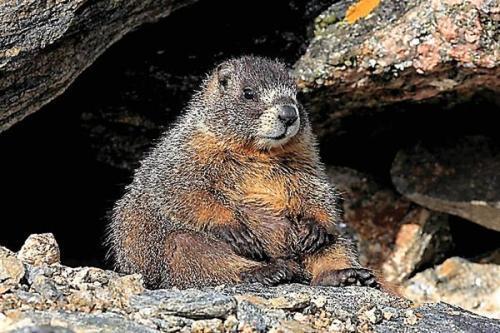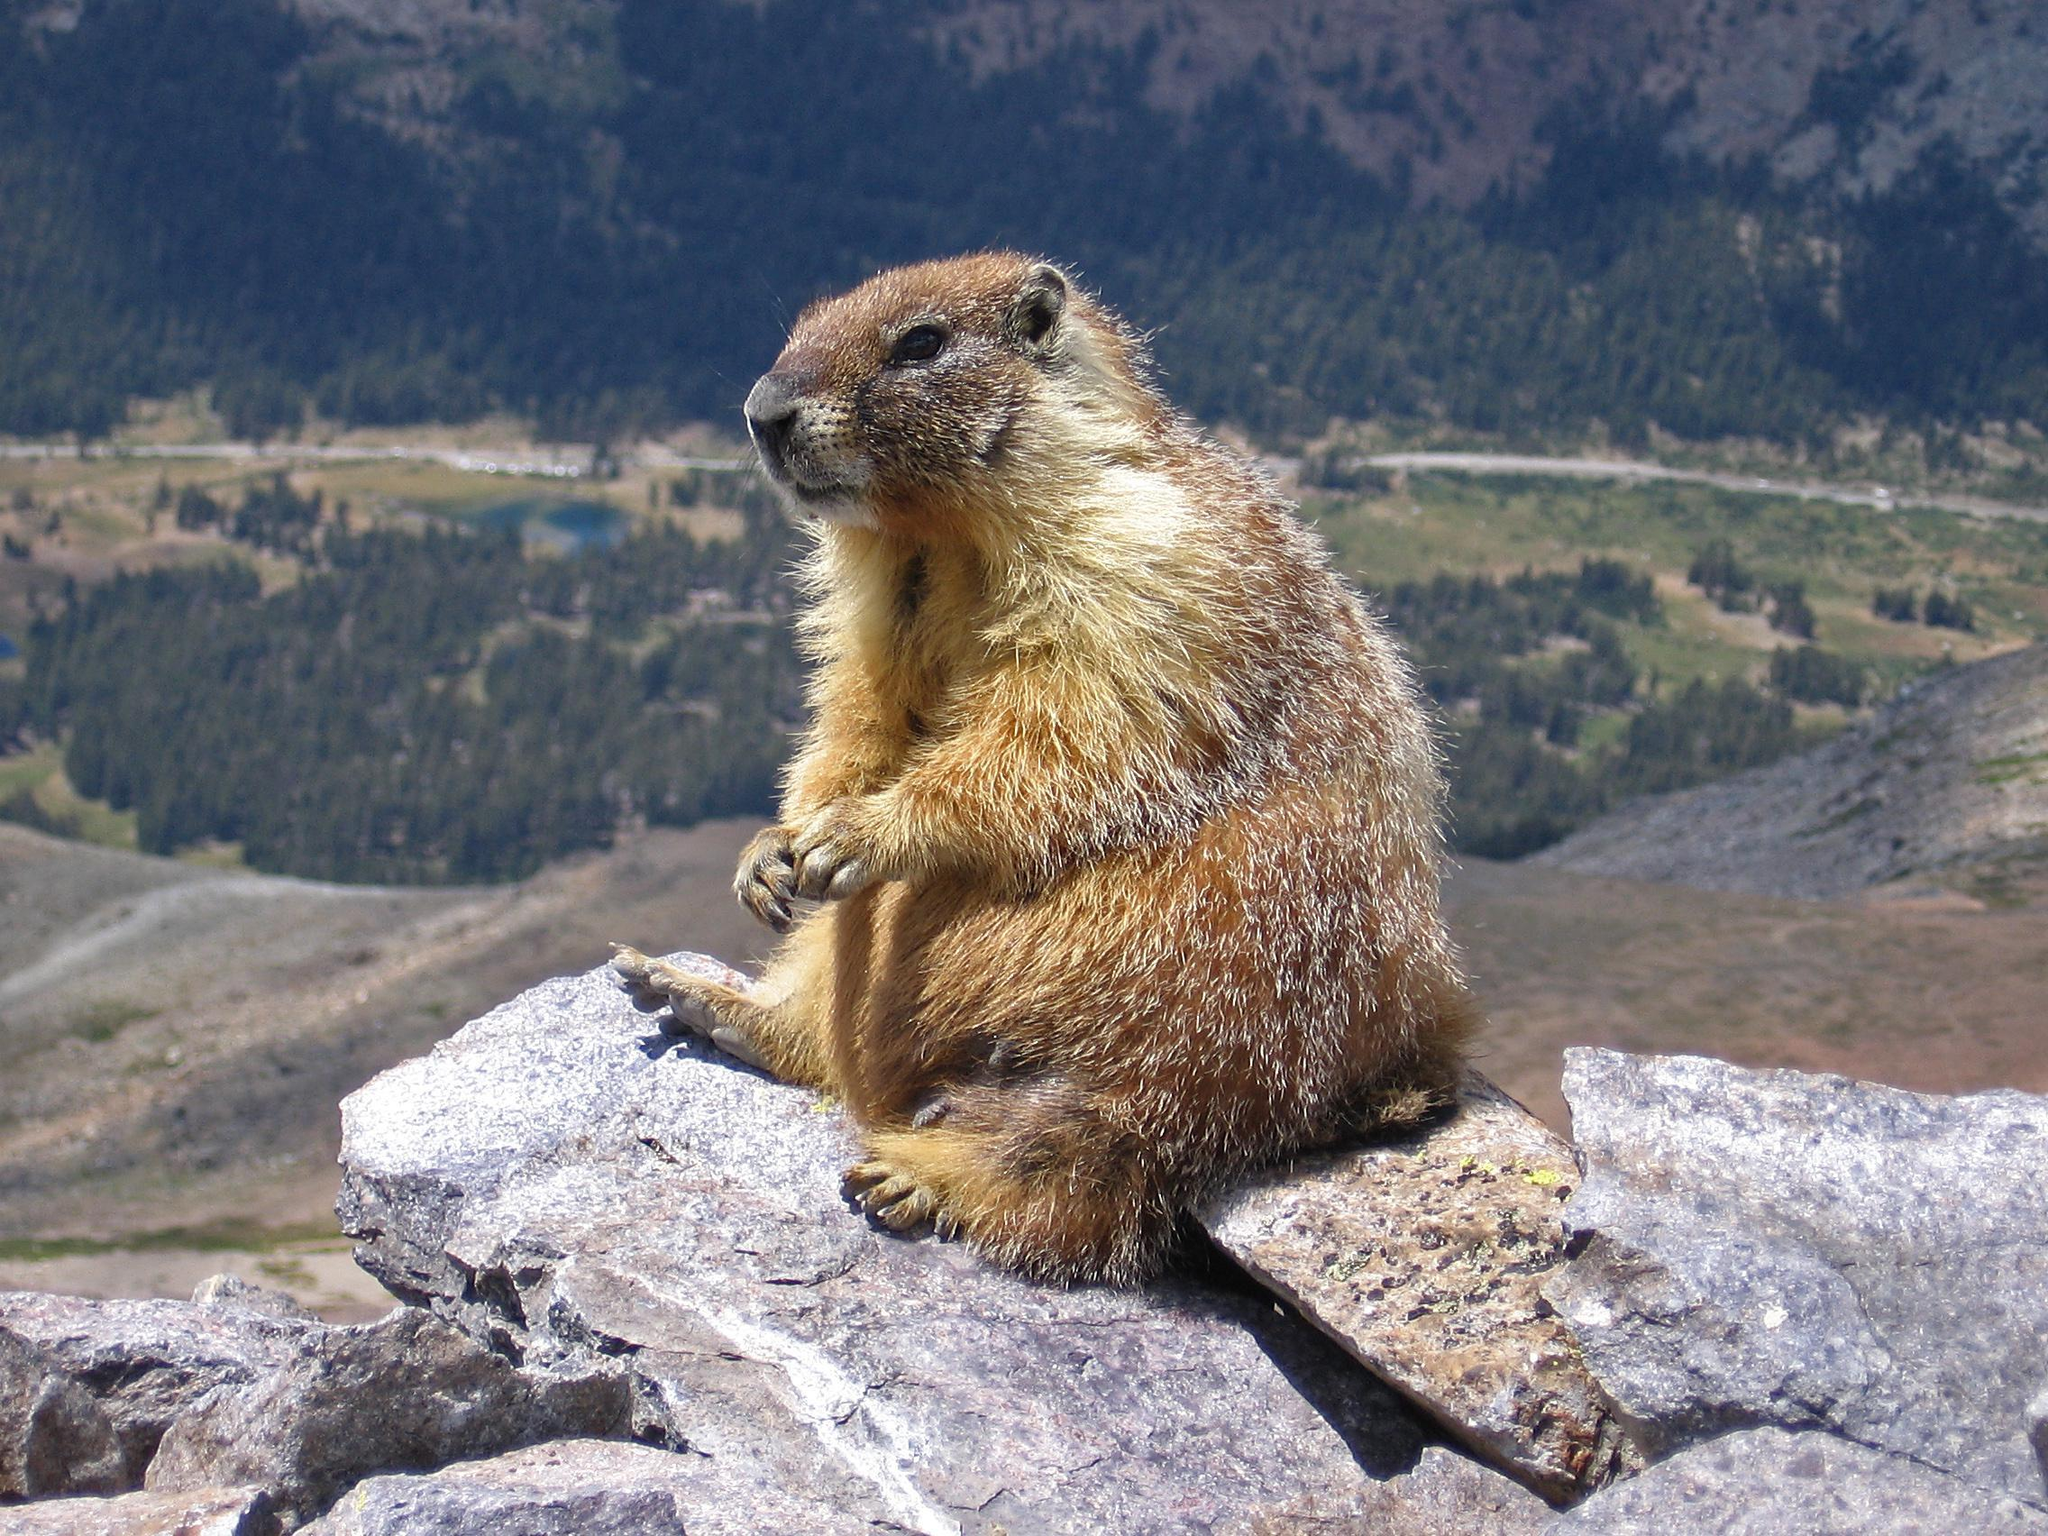The first image is the image on the left, the second image is the image on the right. Considering the images on both sides, is "An image shows a marmot posed on all fours on a rock, and the image contains only one rock." valid? Answer yes or no. No. The first image is the image on the left, the second image is the image on the right. Assess this claim about the two images: "A type of rodent is sitting on a rock with both front legs up in the air.". Correct or not? Answer yes or no. Yes. 